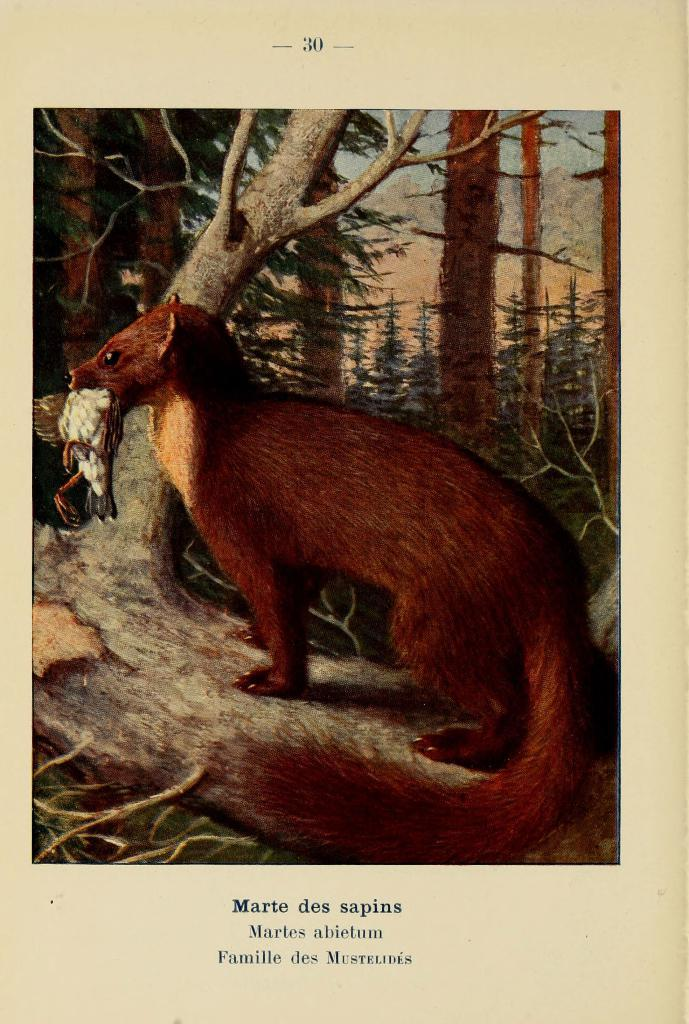What type of living creature is in the image? There is an animal in the image. What can be seen in the background of the image? There are trees in the image. What is written on the paper at the bottom of the image? There is text on a paper at the bottom of the image. How many stamps are on the animal in the image? There are no stamps visible on the animal in the image. 